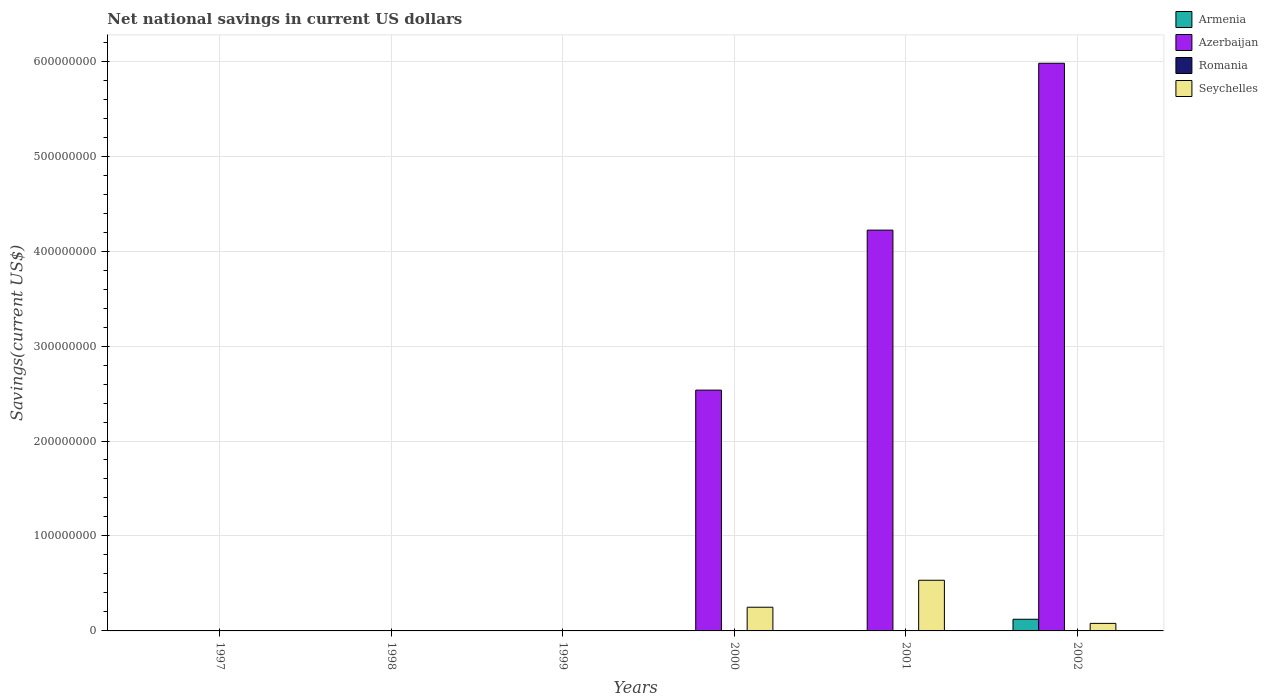How many different coloured bars are there?
Give a very brief answer. 3. Are the number of bars on each tick of the X-axis equal?
Your answer should be very brief. No. How many bars are there on the 2nd tick from the right?
Keep it short and to the point. 2. In how many cases, is the number of bars for a given year not equal to the number of legend labels?
Your response must be concise. 6. What is the net national savings in Azerbaijan in 2001?
Provide a short and direct response. 4.22e+08. Across all years, what is the maximum net national savings in Seychelles?
Give a very brief answer. 5.33e+07. In which year was the net national savings in Seychelles maximum?
Give a very brief answer. 2001. What is the total net national savings in Azerbaijan in the graph?
Your answer should be compact. 1.27e+09. What is the difference between the net national savings in Seychelles in 2000 and that in 2002?
Offer a terse response. 1.70e+07. What is the difference between the net national savings in Seychelles in 2000 and the net national savings in Armenia in 1997?
Offer a terse response. 2.50e+07. What is the average net national savings in Armenia per year?
Your response must be concise. 2.05e+06. In the year 2002, what is the difference between the net national savings in Azerbaijan and net national savings in Seychelles?
Provide a succinct answer. 5.90e+08. In how many years, is the net national savings in Armenia greater than 380000000 US$?
Provide a succinct answer. 0. What is the ratio of the net national savings in Azerbaijan in 2000 to that in 2001?
Ensure brevity in your answer.  0.6. What is the difference between the highest and the second highest net national savings in Azerbaijan?
Offer a very short reply. 1.76e+08. What is the difference between the highest and the lowest net national savings in Armenia?
Offer a terse response. 1.23e+07. Is it the case that in every year, the sum of the net national savings in Romania and net national savings in Seychelles is greater than the sum of net national savings in Armenia and net national savings in Azerbaijan?
Make the answer very short. No. Is it the case that in every year, the sum of the net national savings in Armenia and net national savings in Azerbaijan is greater than the net national savings in Seychelles?
Your answer should be very brief. No. Are all the bars in the graph horizontal?
Offer a terse response. No. Are the values on the major ticks of Y-axis written in scientific E-notation?
Offer a very short reply. No. Does the graph contain grids?
Your answer should be very brief. Yes. How many legend labels are there?
Your answer should be very brief. 4. How are the legend labels stacked?
Give a very brief answer. Vertical. What is the title of the graph?
Offer a very short reply. Net national savings in current US dollars. Does "High income" appear as one of the legend labels in the graph?
Your answer should be very brief. No. What is the label or title of the X-axis?
Your response must be concise. Years. What is the label or title of the Y-axis?
Your answer should be very brief. Savings(current US$). What is the Savings(current US$) in Romania in 1997?
Your answer should be compact. 0. What is the Savings(current US$) in Seychelles in 1997?
Your response must be concise. 0. What is the Savings(current US$) of Azerbaijan in 1998?
Provide a succinct answer. 0. What is the Savings(current US$) in Romania in 1998?
Make the answer very short. 0. What is the Savings(current US$) of Azerbaijan in 1999?
Offer a very short reply. 0. What is the Savings(current US$) of Azerbaijan in 2000?
Offer a very short reply. 2.54e+08. What is the Savings(current US$) in Romania in 2000?
Give a very brief answer. 0. What is the Savings(current US$) in Seychelles in 2000?
Provide a succinct answer. 2.50e+07. What is the Savings(current US$) in Armenia in 2001?
Your answer should be very brief. 0. What is the Savings(current US$) in Azerbaijan in 2001?
Offer a terse response. 4.22e+08. What is the Savings(current US$) of Romania in 2001?
Make the answer very short. 0. What is the Savings(current US$) of Seychelles in 2001?
Your response must be concise. 5.33e+07. What is the Savings(current US$) in Armenia in 2002?
Your answer should be compact. 1.23e+07. What is the Savings(current US$) in Azerbaijan in 2002?
Your answer should be compact. 5.98e+08. What is the Savings(current US$) of Seychelles in 2002?
Give a very brief answer. 7.94e+06. Across all years, what is the maximum Savings(current US$) of Armenia?
Give a very brief answer. 1.23e+07. Across all years, what is the maximum Savings(current US$) in Azerbaijan?
Give a very brief answer. 5.98e+08. Across all years, what is the maximum Savings(current US$) of Seychelles?
Offer a very short reply. 5.33e+07. Across all years, what is the minimum Savings(current US$) of Armenia?
Provide a succinct answer. 0. Across all years, what is the minimum Savings(current US$) in Azerbaijan?
Your answer should be compact. 0. What is the total Savings(current US$) of Armenia in the graph?
Your response must be concise. 1.23e+07. What is the total Savings(current US$) in Azerbaijan in the graph?
Give a very brief answer. 1.27e+09. What is the total Savings(current US$) of Seychelles in the graph?
Give a very brief answer. 8.62e+07. What is the difference between the Savings(current US$) of Azerbaijan in 2000 and that in 2001?
Ensure brevity in your answer.  -1.68e+08. What is the difference between the Savings(current US$) in Seychelles in 2000 and that in 2001?
Offer a very short reply. -2.84e+07. What is the difference between the Savings(current US$) in Azerbaijan in 2000 and that in 2002?
Give a very brief answer. -3.44e+08. What is the difference between the Savings(current US$) in Seychelles in 2000 and that in 2002?
Your response must be concise. 1.70e+07. What is the difference between the Savings(current US$) of Azerbaijan in 2001 and that in 2002?
Make the answer very short. -1.76e+08. What is the difference between the Savings(current US$) in Seychelles in 2001 and that in 2002?
Provide a succinct answer. 4.54e+07. What is the difference between the Savings(current US$) in Azerbaijan in 2000 and the Savings(current US$) in Seychelles in 2001?
Offer a very short reply. 2.00e+08. What is the difference between the Savings(current US$) in Azerbaijan in 2000 and the Savings(current US$) in Seychelles in 2002?
Offer a terse response. 2.46e+08. What is the difference between the Savings(current US$) in Azerbaijan in 2001 and the Savings(current US$) in Seychelles in 2002?
Provide a short and direct response. 4.14e+08. What is the average Savings(current US$) of Armenia per year?
Give a very brief answer. 2.05e+06. What is the average Savings(current US$) in Azerbaijan per year?
Give a very brief answer. 2.12e+08. What is the average Savings(current US$) of Romania per year?
Your response must be concise. 0. What is the average Savings(current US$) of Seychelles per year?
Provide a succinct answer. 1.44e+07. In the year 2000, what is the difference between the Savings(current US$) of Azerbaijan and Savings(current US$) of Seychelles?
Your answer should be compact. 2.29e+08. In the year 2001, what is the difference between the Savings(current US$) in Azerbaijan and Savings(current US$) in Seychelles?
Offer a very short reply. 3.69e+08. In the year 2002, what is the difference between the Savings(current US$) in Armenia and Savings(current US$) in Azerbaijan?
Your answer should be compact. -5.86e+08. In the year 2002, what is the difference between the Savings(current US$) of Armenia and Savings(current US$) of Seychelles?
Your answer should be very brief. 4.34e+06. In the year 2002, what is the difference between the Savings(current US$) in Azerbaijan and Savings(current US$) in Seychelles?
Your answer should be very brief. 5.90e+08. What is the ratio of the Savings(current US$) in Azerbaijan in 2000 to that in 2001?
Your response must be concise. 0.6. What is the ratio of the Savings(current US$) of Seychelles in 2000 to that in 2001?
Your answer should be compact. 0.47. What is the ratio of the Savings(current US$) in Azerbaijan in 2000 to that in 2002?
Give a very brief answer. 0.42. What is the ratio of the Savings(current US$) of Seychelles in 2000 to that in 2002?
Ensure brevity in your answer.  3.14. What is the ratio of the Savings(current US$) of Azerbaijan in 2001 to that in 2002?
Your answer should be very brief. 0.71. What is the ratio of the Savings(current US$) of Seychelles in 2001 to that in 2002?
Keep it short and to the point. 6.72. What is the difference between the highest and the second highest Savings(current US$) of Azerbaijan?
Your response must be concise. 1.76e+08. What is the difference between the highest and the second highest Savings(current US$) in Seychelles?
Your answer should be compact. 2.84e+07. What is the difference between the highest and the lowest Savings(current US$) in Armenia?
Make the answer very short. 1.23e+07. What is the difference between the highest and the lowest Savings(current US$) in Azerbaijan?
Provide a succinct answer. 5.98e+08. What is the difference between the highest and the lowest Savings(current US$) in Seychelles?
Keep it short and to the point. 5.33e+07. 